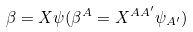<formula> <loc_0><loc_0><loc_500><loc_500>\beta = X \psi ( \beta ^ { A } = X ^ { A A ^ { \prime } } \psi _ { A ^ { \prime } } )</formula> 